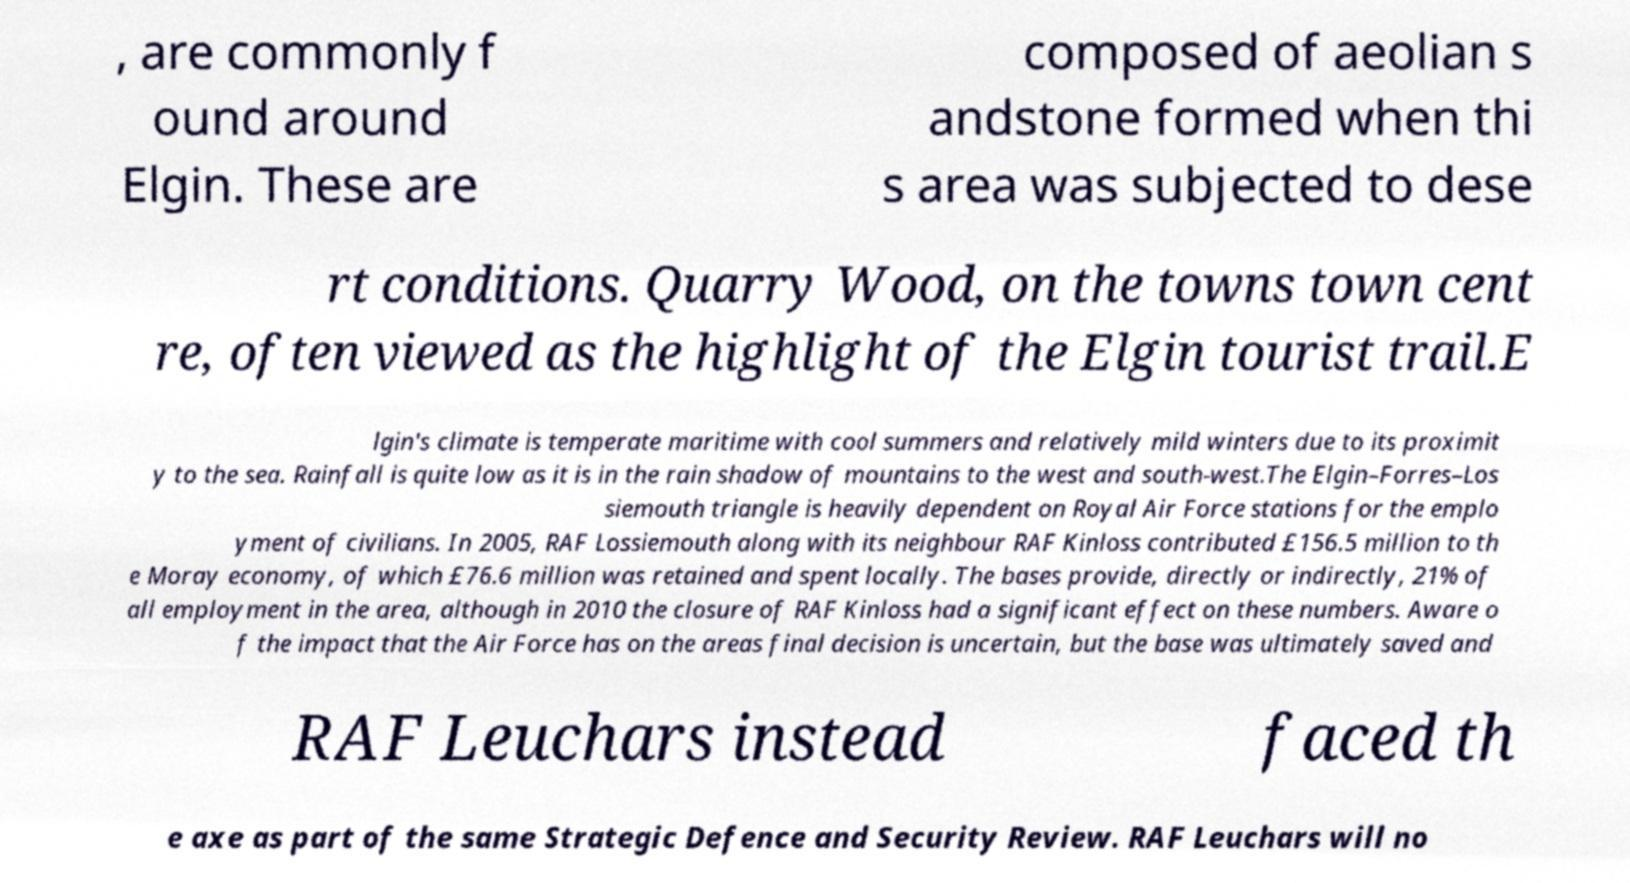What messages or text are displayed in this image? I need them in a readable, typed format. , are commonly f ound around Elgin. These are composed of aeolian s andstone formed when thi s area was subjected to dese rt conditions. Quarry Wood, on the towns town cent re, often viewed as the highlight of the Elgin tourist trail.E lgin's climate is temperate maritime with cool summers and relatively mild winters due to its proximit y to the sea. Rainfall is quite low as it is in the rain shadow of mountains to the west and south-west.The Elgin–Forres–Los siemouth triangle is heavily dependent on Royal Air Force stations for the emplo yment of civilians. In 2005, RAF Lossiemouth along with its neighbour RAF Kinloss contributed £156.5 million to th e Moray economy, of which £76.6 million was retained and spent locally. The bases provide, directly or indirectly, 21% of all employment in the area, although in 2010 the closure of RAF Kinloss had a significant effect on these numbers. Aware o f the impact that the Air Force has on the areas final decision is uncertain, but the base was ultimately saved and RAF Leuchars instead faced th e axe as part of the same Strategic Defence and Security Review. RAF Leuchars will no 